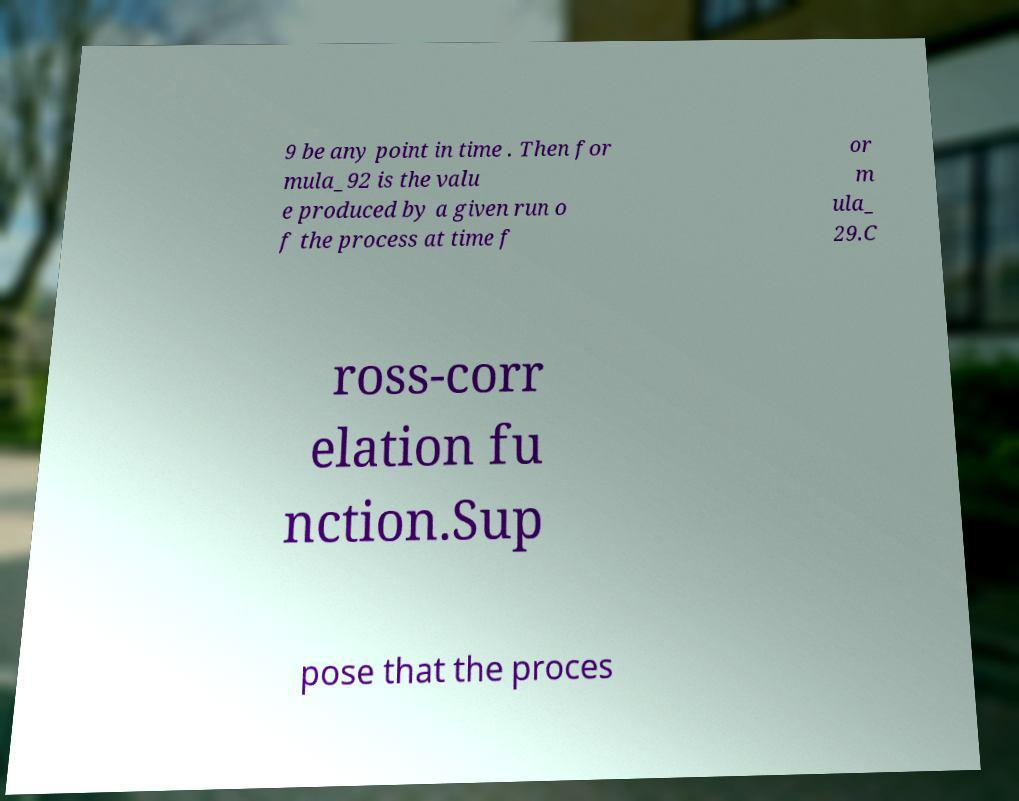Can you read and provide the text displayed in the image?This photo seems to have some interesting text. Can you extract and type it out for me? 9 be any point in time . Then for mula_92 is the valu e produced by a given run o f the process at time f or m ula_ 29.C ross-corr elation fu nction.Sup pose that the proces 